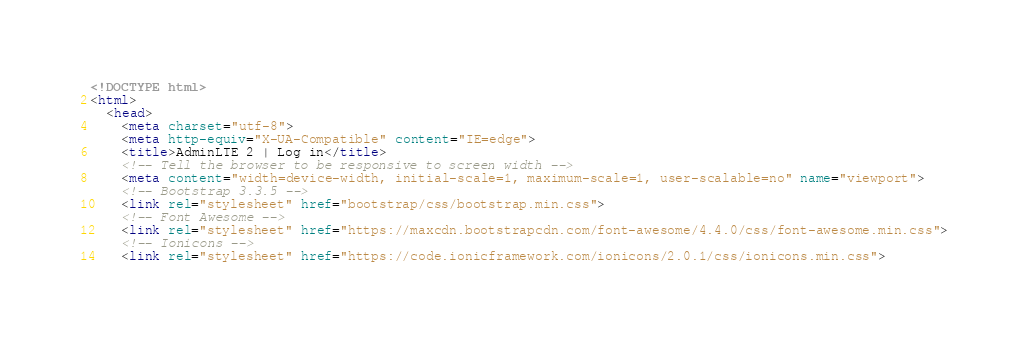Convert code to text. <code><loc_0><loc_0><loc_500><loc_500><_HTML_><!DOCTYPE html>
<html>
  <head>
    <meta charset="utf-8">
    <meta http-equiv="X-UA-Compatible" content="IE=edge">
    <title>AdminLTE 2 | Log in</title>
    <!-- Tell the browser to be responsive to screen width -->
    <meta content="width=device-width, initial-scale=1, maximum-scale=1, user-scalable=no" name="viewport">
    <!-- Bootstrap 3.3.5 -->
    <link rel="stylesheet" href="bootstrap/css/bootstrap.min.css">
    <!-- Font Awesome -->
    <link rel="stylesheet" href="https://maxcdn.bootstrapcdn.com/font-awesome/4.4.0/css/font-awesome.min.css">
    <!-- Ionicons -->
    <link rel="stylesheet" href="https://code.ionicframework.com/ionicons/2.0.1/css/ionicons.min.css"></code> 